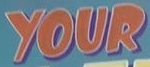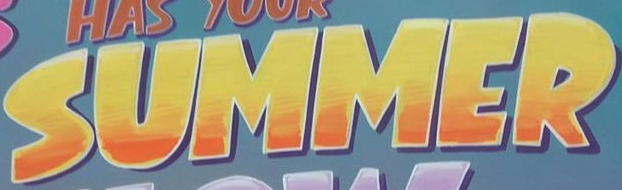Identify the words shown in these images in order, separated by a semicolon. YOUR; SUMMER 